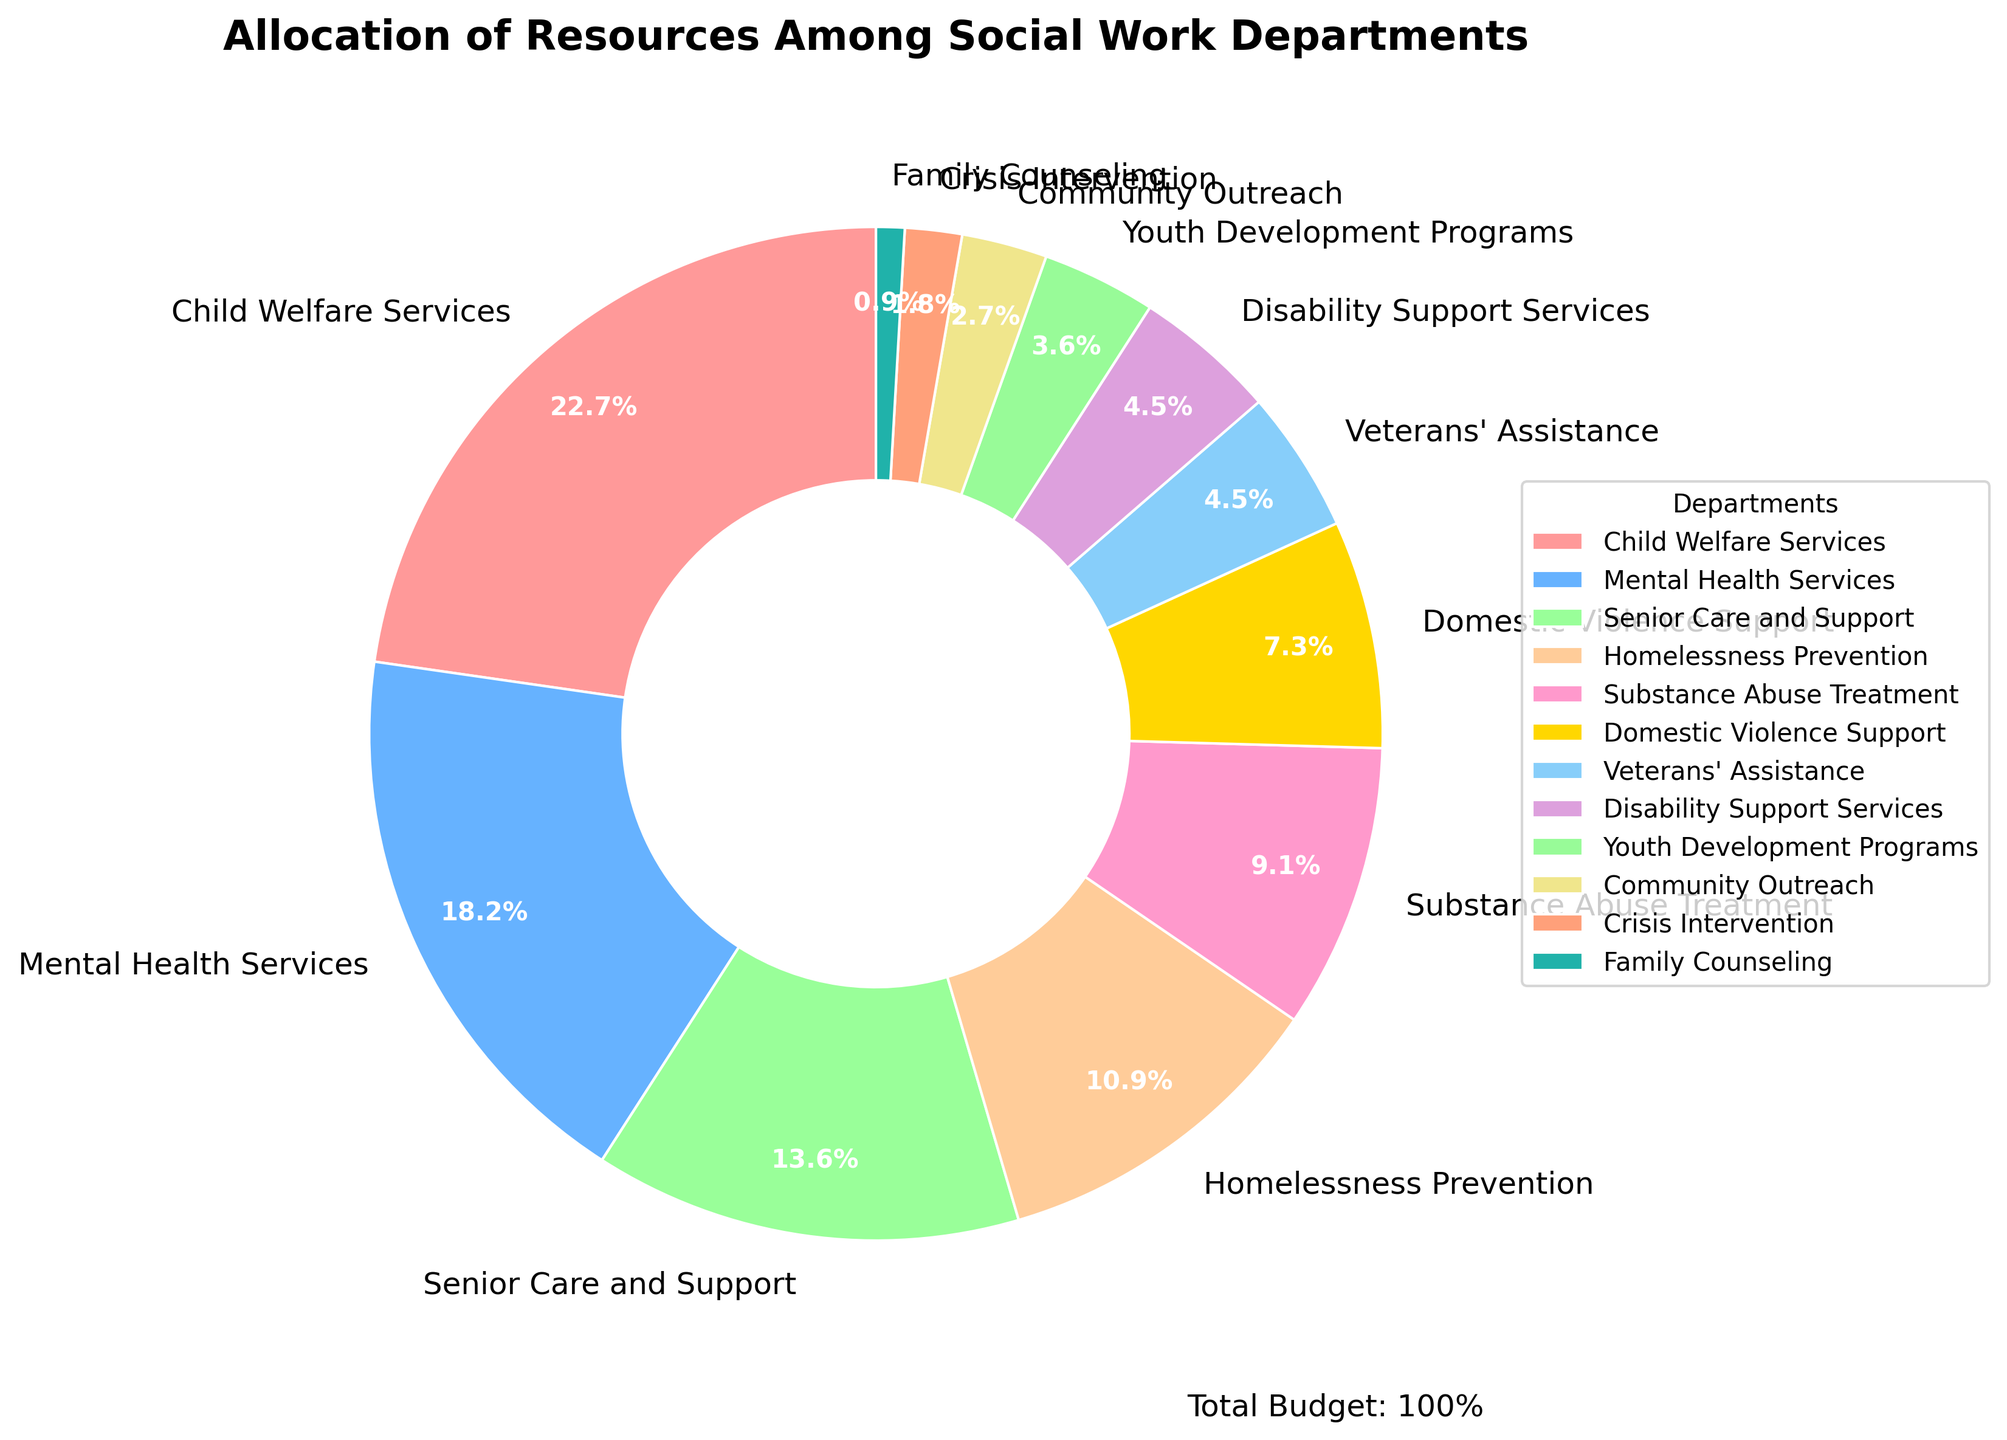What's the department with the highest allocation percentage? Identify the department with the highest percentage in the chart. The largest slice represents Child Welfare Services with 25%.
Answer: Child Welfare Services Which department receives the least allocation? Look for the smallest slice in the pie chart, represented by Family Counseling with 1%.
Answer: Family Counseling What's the combined allocation percentage for Domestic Violence Support and Veterans' Assistance? Add the percentages of Domestic Violence Support (8%) and Veterans' Assistance (5%). 8% + 5% = 13%
Answer: 13% Does Senior Care and Support receive more funding than Substance Abuse Treatment? Compare the percentages of Senior Care and Support (15%) and Substance Abuse Treatment (10%). 15% is greater than 10%.
Answer: Yes What's the total percentage allocation for departments with less than 10% each? Sum the percentages of departments with less than 10%: Substance Abuse Treatment (10%), Domestic Violence Support (8%), Veterans' Assistance (5%), Disability Support Services (5%), Youth Development Programs (4%), Community Outreach (3%), Crisis Intervention (2%), Family Counseling (1%). 10% + 8% + 5% + 5% + 4% + 3% + 2% + 1% = 38%
Answer: 38% Which department has a higher allocation, Crisis Intervention or Youth Development Programs? Compare the percentages for Crisis Intervention (2%) and Youth Development Programs (4%). 4% is greater than 2%.
Answer: Youth Development Programs Is the allocation for Homelessness Prevention more than twice that of Family Counseling? Check if the percentage for Homelessness Prevention (12%) is more than twice the percentage for Family Counseling (1%). 2 times 1% is 2%, and 12% is greater than 2%.
Answer: Yes What is the total percentage for Child Welfare Services, Mental Health Services, and Senior Care and Support? Sum their percentages: Child Welfare Services (25%), Mental Health Services (20%), Senior Care and Support (15%). 25% + 20% + 15% = 60%
Answer: 60% Approximately what percentage of resources is allocated to programs supporting vulnerable adults (Senior Care, Homelessness Prevention, Substance Abuse Treatment, Domestic Violence Support)? Sum their percentages: Senior Care (15%), Homelessness Prevention (12%), Substance Abuse Treatment (10%), Domestic Violence Support (8%). 15% + 12% + 10% + 8% = 45%
Answer: 45% How does the allocation for Crisis Intervention compare to that for Community Outreach? Compare the percentages for Crisis Intervention (2%) and Community Outreach (3%). 3% is greater than 2%.
Answer: Community Outreach 